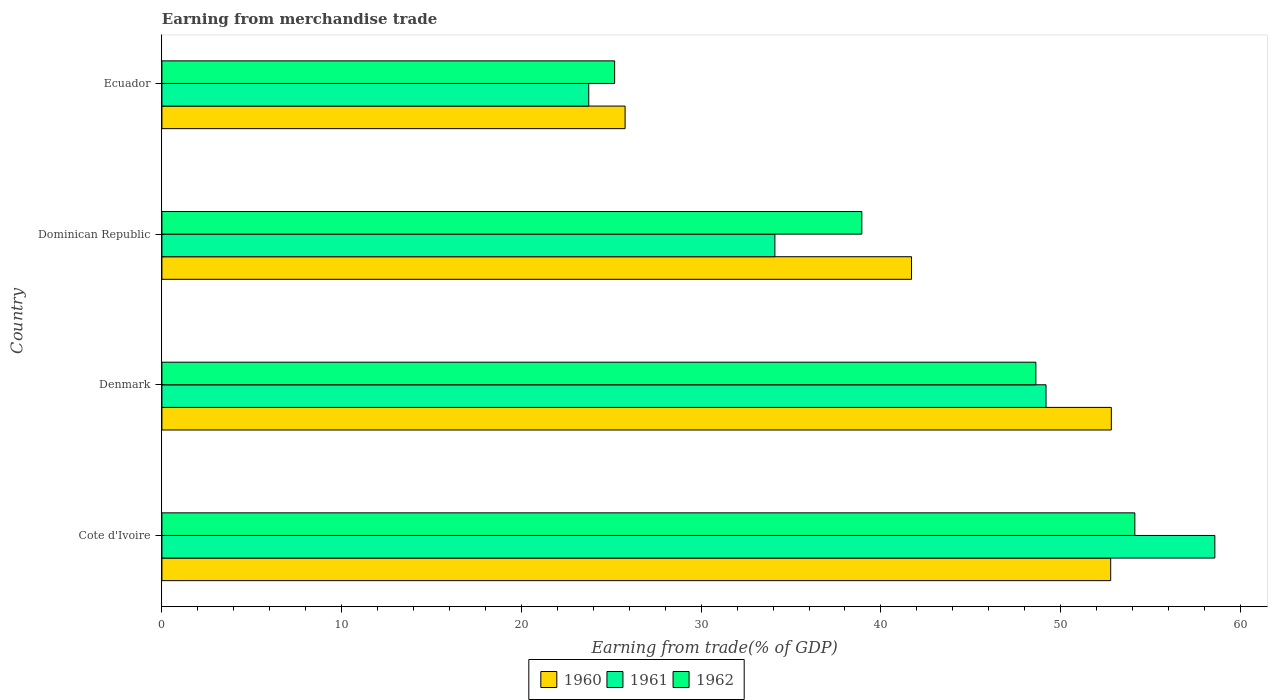How many different coloured bars are there?
Your response must be concise. 3. How many groups of bars are there?
Give a very brief answer. 4. Are the number of bars per tick equal to the number of legend labels?
Ensure brevity in your answer.  Yes. Are the number of bars on each tick of the Y-axis equal?
Ensure brevity in your answer.  Yes. In how many cases, is the number of bars for a given country not equal to the number of legend labels?
Offer a terse response. 0. What is the earnings from trade in 1962 in Dominican Republic?
Offer a terse response. 38.94. Across all countries, what is the maximum earnings from trade in 1960?
Keep it short and to the point. 52.82. Across all countries, what is the minimum earnings from trade in 1961?
Make the answer very short. 23.75. In which country was the earnings from trade in 1962 maximum?
Your answer should be very brief. Cote d'Ivoire. In which country was the earnings from trade in 1962 minimum?
Ensure brevity in your answer.  Ecuador. What is the total earnings from trade in 1961 in the graph?
Ensure brevity in your answer.  165.62. What is the difference between the earnings from trade in 1961 in Cote d'Ivoire and that in Ecuador?
Make the answer very short. 34.83. What is the difference between the earnings from trade in 1962 in Cote d'Ivoire and the earnings from trade in 1961 in Dominican Republic?
Make the answer very short. 20.03. What is the average earnings from trade in 1960 per country?
Your answer should be compact. 43.27. What is the difference between the earnings from trade in 1961 and earnings from trade in 1960 in Dominican Republic?
Provide a short and direct response. -7.6. What is the ratio of the earnings from trade in 1962 in Cote d'Ivoire to that in Dominican Republic?
Ensure brevity in your answer.  1.39. Is the earnings from trade in 1961 in Dominican Republic less than that in Ecuador?
Ensure brevity in your answer.  No. Is the difference between the earnings from trade in 1961 in Dominican Republic and Ecuador greater than the difference between the earnings from trade in 1960 in Dominican Republic and Ecuador?
Your response must be concise. No. What is the difference between the highest and the second highest earnings from trade in 1961?
Give a very brief answer. 9.39. What is the difference between the highest and the lowest earnings from trade in 1962?
Provide a succinct answer. 28.94. Is the sum of the earnings from trade in 1962 in Denmark and Ecuador greater than the maximum earnings from trade in 1961 across all countries?
Your answer should be compact. Yes. What does the 3rd bar from the top in Dominican Republic represents?
Your answer should be compact. 1960. What does the 2nd bar from the bottom in Cote d'Ivoire represents?
Give a very brief answer. 1961. Is it the case that in every country, the sum of the earnings from trade in 1960 and earnings from trade in 1962 is greater than the earnings from trade in 1961?
Make the answer very short. Yes. How many bars are there?
Ensure brevity in your answer.  12. Are all the bars in the graph horizontal?
Your answer should be compact. Yes. What is the difference between two consecutive major ticks on the X-axis?
Ensure brevity in your answer.  10. Does the graph contain any zero values?
Your answer should be compact. No. Where does the legend appear in the graph?
Make the answer very short. Bottom center. How many legend labels are there?
Provide a succinct answer. 3. How are the legend labels stacked?
Offer a terse response. Horizontal. What is the title of the graph?
Your answer should be compact. Earning from merchandise trade. What is the label or title of the X-axis?
Provide a short and direct response. Earning from trade(% of GDP). What is the label or title of the Y-axis?
Provide a short and direct response. Country. What is the Earning from trade(% of GDP) of 1960 in Cote d'Ivoire?
Keep it short and to the point. 52.78. What is the Earning from trade(% of GDP) of 1961 in Cote d'Ivoire?
Provide a short and direct response. 58.58. What is the Earning from trade(% of GDP) in 1962 in Cote d'Ivoire?
Offer a terse response. 54.13. What is the Earning from trade(% of GDP) of 1960 in Denmark?
Make the answer very short. 52.82. What is the Earning from trade(% of GDP) in 1961 in Denmark?
Your answer should be compact. 49.19. What is the Earning from trade(% of GDP) in 1962 in Denmark?
Make the answer very short. 48.62. What is the Earning from trade(% of GDP) of 1960 in Dominican Republic?
Your answer should be very brief. 41.7. What is the Earning from trade(% of GDP) in 1961 in Dominican Republic?
Offer a terse response. 34.1. What is the Earning from trade(% of GDP) of 1962 in Dominican Republic?
Offer a terse response. 38.94. What is the Earning from trade(% of GDP) in 1960 in Ecuador?
Your answer should be compact. 25.77. What is the Earning from trade(% of GDP) in 1961 in Ecuador?
Your answer should be very brief. 23.75. What is the Earning from trade(% of GDP) in 1962 in Ecuador?
Your answer should be very brief. 25.19. Across all countries, what is the maximum Earning from trade(% of GDP) of 1960?
Give a very brief answer. 52.82. Across all countries, what is the maximum Earning from trade(% of GDP) in 1961?
Ensure brevity in your answer.  58.58. Across all countries, what is the maximum Earning from trade(% of GDP) of 1962?
Offer a very short reply. 54.13. Across all countries, what is the minimum Earning from trade(% of GDP) in 1960?
Give a very brief answer. 25.77. Across all countries, what is the minimum Earning from trade(% of GDP) of 1961?
Provide a succinct answer. 23.75. Across all countries, what is the minimum Earning from trade(% of GDP) in 1962?
Make the answer very short. 25.19. What is the total Earning from trade(% of GDP) in 1960 in the graph?
Make the answer very short. 173.08. What is the total Earning from trade(% of GDP) in 1961 in the graph?
Your answer should be compact. 165.62. What is the total Earning from trade(% of GDP) in 1962 in the graph?
Offer a terse response. 166.88. What is the difference between the Earning from trade(% of GDP) in 1960 in Cote d'Ivoire and that in Denmark?
Offer a terse response. -0.04. What is the difference between the Earning from trade(% of GDP) of 1961 in Cote d'Ivoire and that in Denmark?
Provide a succinct answer. 9.39. What is the difference between the Earning from trade(% of GDP) in 1962 in Cote d'Ivoire and that in Denmark?
Your response must be concise. 5.51. What is the difference between the Earning from trade(% of GDP) of 1960 in Cote d'Ivoire and that in Dominican Republic?
Ensure brevity in your answer.  11.08. What is the difference between the Earning from trade(% of GDP) of 1961 in Cote d'Ivoire and that in Dominican Republic?
Make the answer very short. 24.48. What is the difference between the Earning from trade(% of GDP) in 1962 in Cote d'Ivoire and that in Dominican Republic?
Offer a very short reply. 15.19. What is the difference between the Earning from trade(% of GDP) of 1960 in Cote d'Ivoire and that in Ecuador?
Provide a succinct answer. 27.01. What is the difference between the Earning from trade(% of GDP) in 1961 in Cote d'Ivoire and that in Ecuador?
Your response must be concise. 34.83. What is the difference between the Earning from trade(% of GDP) of 1962 in Cote d'Ivoire and that in Ecuador?
Your answer should be very brief. 28.94. What is the difference between the Earning from trade(% of GDP) of 1960 in Denmark and that in Dominican Republic?
Provide a succinct answer. 11.11. What is the difference between the Earning from trade(% of GDP) in 1961 in Denmark and that in Dominican Republic?
Your answer should be compact. 15.08. What is the difference between the Earning from trade(% of GDP) of 1962 in Denmark and that in Dominican Republic?
Keep it short and to the point. 9.68. What is the difference between the Earning from trade(% of GDP) of 1960 in Denmark and that in Ecuador?
Provide a succinct answer. 27.05. What is the difference between the Earning from trade(% of GDP) in 1961 in Denmark and that in Ecuador?
Your response must be concise. 25.44. What is the difference between the Earning from trade(% of GDP) of 1962 in Denmark and that in Ecuador?
Your answer should be very brief. 23.44. What is the difference between the Earning from trade(% of GDP) in 1960 in Dominican Republic and that in Ecuador?
Give a very brief answer. 15.94. What is the difference between the Earning from trade(% of GDP) of 1961 in Dominican Republic and that in Ecuador?
Your response must be concise. 10.36. What is the difference between the Earning from trade(% of GDP) in 1962 in Dominican Republic and that in Ecuador?
Give a very brief answer. 13.75. What is the difference between the Earning from trade(% of GDP) of 1960 in Cote d'Ivoire and the Earning from trade(% of GDP) of 1961 in Denmark?
Keep it short and to the point. 3.6. What is the difference between the Earning from trade(% of GDP) in 1960 in Cote d'Ivoire and the Earning from trade(% of GDP) in 1962 in Denmark?
Provide a succinct answer. 4.16. What is the difference between the Earning from trade(% of GDP) in 1961 in Cote d'Ivoire and the Earning from trade(% of GDP) in 1962 in Denmark?
Your response must be concise. 9.96. What is the difference between the Earning from trade(% of GDP) in 1960 in Cote d'Ivoire and the Earning from trade(% of GDP) in 1961 in Dominican Republic?
Keep it short and to the point. 18.68. What is the difference between the Earning from trade(% of GDP) of 1960 in Cote d'Ivoire and the Earning from trade(% of GDP) of 1962 in Dominican Republic?
Offer a terse response. 13.85. What is the difference between the Earning from trade(% of GDP) in 1961 in Cote d'Ivoire and the Earning from trade(% of GDP) in 1962 in Dominican Republic?
Your response must be concise. 19.64. What is the difference between the Earning from trade(% of GDP) of 1960 in Cote d'Ivoire and the Earning from trade(% of GDP) of 1961 in Ecuador?
Provide a succinct answer. 29.04. What is the difference between the Earning from trade(% of GDP) of 1960 in Cote d'Ivoire and the Earning from trade(% of GDP) of 1962 in Ecuador?
Provide a succinct answer. 27.6. What is the difference between the Earning from trade(% of GDP) of 1961 in Cote d'Ivoire and the Earning from trade(% of GDP) of 1962 in Ecuador?
Offer a terse response. 33.39. What is the difference between the Earning from trade(% of GDP) in 1960 in Denmark and the Earning from trade(% of GDP) in 1961 in Dominican Republic?
Provide a succinct answer. 18.72. What is the difference between the Earning from trade(% of GDP) of 1960 in Denmark and the Earning from trade(% of GDP) of 1962 in Dominican Republic?
Your answer should be compact. 13.88. What is the difference between the Earning from trade(% of GDP) in 1961 in Denmark and the Earning from trade(% of GDP) in 1962 in Dominican Republic?
Give a very brief answer. 10.25. What is the difference between the Earning from trade(% of GDP) of 1960 in Denmark and the Earning from trade(% of GDP) of 1961 in Ecuador?
Offer a terse response. 29.07. What is the difference between the Earning from trade(% of GDP) of 1960 in Denmark and the Earning from trade(% of GDP) of 1962 in Ecuador?
Provide a short and direct response. 27.63. What is the difference between the Earning from trade(% of GDP) of 1961 in Denmark and the Earning from trade(% of GDP) of 1962 in Ecuador?
Give a very brief answer. 24. What is the difference between the Earning from trade(% of GDP) of 1960 in Dominican Republic and the Earning from trade(% of GDP) of 1961 in Ecuador?
Provide a short and direct response. 17.96. What is the difference between the Earning from trade(% of GDP) of 1960 in Dominican Republic and the Earning from trade(% of GDP) of 1962 in Ecuador?
Provide a succinct answer. 16.52. What is the difference between the Earning from trade(% of GDP) of 1961 in Dominican Republic and the Earning from trade(% of GDP) of 1962 in Ecuador?
Your response must be concise. 8.92. What is the average Earning from trade(% of GDP) in 1960 per country?
Your answer should be compact. 43.27. What is the average Earning from trade(% of GDP) of 1961 per country?
Give a very brief answer. 41.4. What is the average Earning from trade(% of GDP) in 1962 per country?
Ensure brevity in your answer.  41.72. What is the difference between the Earning from trade(% of GDP) in 1960 and Earning from trade(% of GDP) in 1961 in Cote d'Ivoire?
Ensure brevity in your answer.  -5.79. What is the difference between the Earning from trade(% of GDP) of 1960 and Earning from trade(% of GDP) of 1962 in Cote d'Ivoire?
Keep it short and to the point. -1.34. What is the difference between the Earning from trade(% of GDP) of 1961 and Earning from trade(% of GDP) of 1962 in Cote d'Ivoire?
Your response must be concise. 4.45. What is the difference between the Earning from trade(% of GDP) in 1960 and Earning from trade(% of GDP) in 1961 in Denmark?
Offer a very short reply. 3.63. What is the difference between the Earning from trade(% of GDP) in 1960 and Earning from trade(% of GDP) in 1962 in Denmark?
Ensure brevity in your answer.  4.2. What is the difference between the Earning from trade(% of GDP) of 1961 and Earning from trade(% of GDP) of 1962 in Denmark?
Ensure brevity in your answer.  0.56. What is the difference between the Earning from trade(% of GDP) of 1960 and Earning from trade(% of GDP) of 1961 in Dominican Republic?
Keep it short and to the point. 7.6. What is the difference between the Earning from trade(% of GDP) of 1960 and Earning from trade(% of GDP) of 1962 in Dominican Republic?
Your answer should be very brief. 2.77. What is the difference between the Earning from trade(% of GDP) of 1961 and Earning from trade(% of GDP) of 1962 in Dominican Republic?
Ensure brevity in your answer.  -4.84. What is the difference between the Earning from trade(% of GDP) in 1960 and Earning from trade(% of GDP) in 1961 in Ecuador?
Offer a terse response. 2.02. What is the difference between the Earning from trade(% of GDP) in 1960 and Earning from trade(% of GDP) in 1962 in Ecuador?
Ensure brevity in your answer.  0.58. What is the difference between the Earning from trade(% of GDP) in 1961 and Earning from trade(% of GDP) in 1962 in Ecuador?
Your answer should be compact. -1.44. What is the ratio of the Earning from trade(% of GDP) in 1961 in Cote d'Ivoire to that in Denmark?
Ensure brevity in your answer.  1.19. What is the ratio of the Earning from trade(% of GDP) of 1962 in Cote d'Ivoire to that in Denmark?
Offer a terse response. 1.11. What is the ratio of the Earning from trade(% of GDP) of 1960 in Cote d'Ivoire to that in Dominican Republic?
Make the answer very short. 1.27. What is the ratio of the Earning from trade(% of GDP) of 1961 in Cote d'Ivoire to that in Dominican Republic?
Offer a terse response. 1.72. What is the ratio of the Earning from trade(% of GDP) in 1962 in Cote d'Ivoire to that in Dominican Republic?
Your answer should be compact. 1.39. What is the ratio of the Earning from trade(% of GDP) of 1960 in Cote d'Ivoire to that in Ecuador?
Give a very brief answer. 2.05. What is the ratio of the Earning from trade(% of GDP) of 1961 in Cote d'Ivoire to that in Ecuador?
Your answer should be compact. 2.47. What is the ratio of the Earning from trade(% of GDP) of 1962 in Cote d'Ivoire to that in Ecuador?
Offer a terse response. 2.15. What is the ratio of the Earning from trade(% of GDP) of 1960 in Denmark to that in Dominican Republic?
Offer a terse response. 1.27. What is the ratio of the Earning from trade(% of GDP) of 1961 in Denmark to that in Dominican Republic?
Give a very brief answer. 1.44. What is the ratio of the Earning from trade(% of GDP) in 1962 in Denmark to that in Dominican Republic?
Your answer should be very brief. 1.25. What is the ratio of the Earning from trade(% of GDP) in 1960 in Denmark to that in Ecuador?
Offer a very short reply. 2.05. What is the ratio of the Earning from trade(% of GDP) of 1961 in Denmark to that in Ecuador?
Provide a succinct answer. 2.07. What is the ratio of the Earning from trade(% of GDP) in 1962 in Denmark to that in Ecuador?
Offer a terse response. 1.93. What is the ratio of the Earning from trade(% of GDP) in 1960 in Dominican Republic to that in Ecuador?
Provide a succinct answer. 1.62. What is the ratio of the Earning from trade(% of GDP) of 1961 in Dominican Republic to that in Ecuador?
Provide a short and direct response. 1.44. What is the ratio of the Earning from trade(% of GDP) of 1962 in Dominican Republic to that in Ecuador?
Give a very brief answer. 1.55. What is the difference between the highest and the second highest Earning from trade(% of GDP) of 1960?
Provide a succinct answer. 0.04. What is the difference between the highest and the second highest Earning from trade(% of GDP) in 1961?
Ensure brevity in your answer.  9.39. What is the difference between the highest and the second highest Earning from trade(% of GDP) of 1962?
Keep it short and to the point. 5.51. What is the difference between the highest and the lowest Earning from trade(% of GDP) in 1960?
Offer a terse response. 27.05. What is the difference between the highest and the lowest Earning from trade(% of GDP) in 1961?
Provide a short and direct response. 34.83. What is the difference between the highest and the lowest Earning from trade(% of GDP) of 1962?
Ensure brevity in your answer.  28.94. 